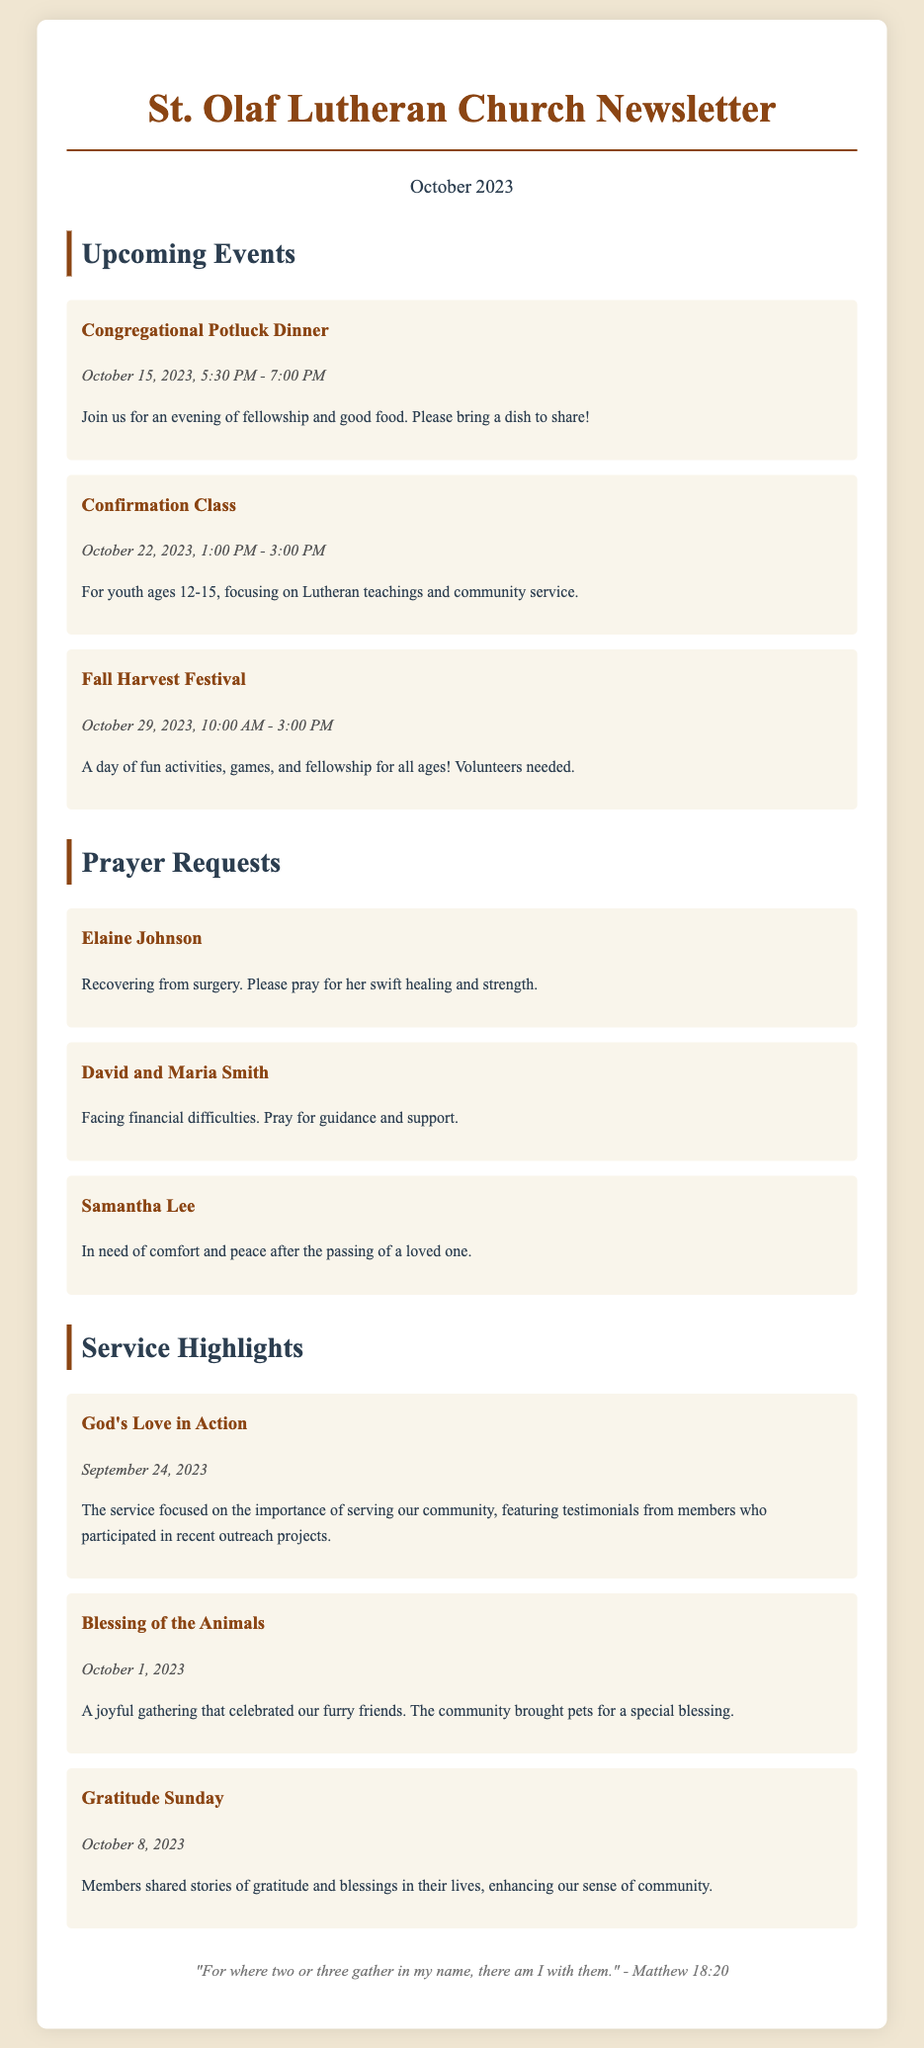What is the title of the newsletter? The title of the newsletter is presented prominently at the top of the document.
Answer: St. Olaf Lutheran Church Newsletter When is the Congregational Potluck Dinner scheduled? The date and time for the event is mentioned directly under its title.
Answer: October 15, 2023, 5:30 PM - 7:00 PM Who is recovering from surgery? The document contains specific names mentioned in the prayer requests section.
Answer: Elaine Johnson What is the theme of the service on September 24, 2023? The theme is summarized in the highlight section and represents the focus of the service.
Answer: God's Love in Action How many prayer requests are featured in the newsletter? The total number of requests is determined by counting the individual entries under the prayer requests section.
Answer: 3 What activity is mentioned to be happening on October 29, 2023? The activity is listed as an event in the upcoming section, indicating the nature of the event.
Answer: Fall Harvest Festival How did members contribute during the service on October 8, 2023? Members are described in the highlights section, providing details on their contributions during the service.
Answer: Shared stories of gratitude and blessings What is the closing quote in the newsletter? The quote is displayed in the footer and provides a biblical reference related to gathering.
Answer: "For where two or three gather in my name, there am I with them." - Matthew 18:20 